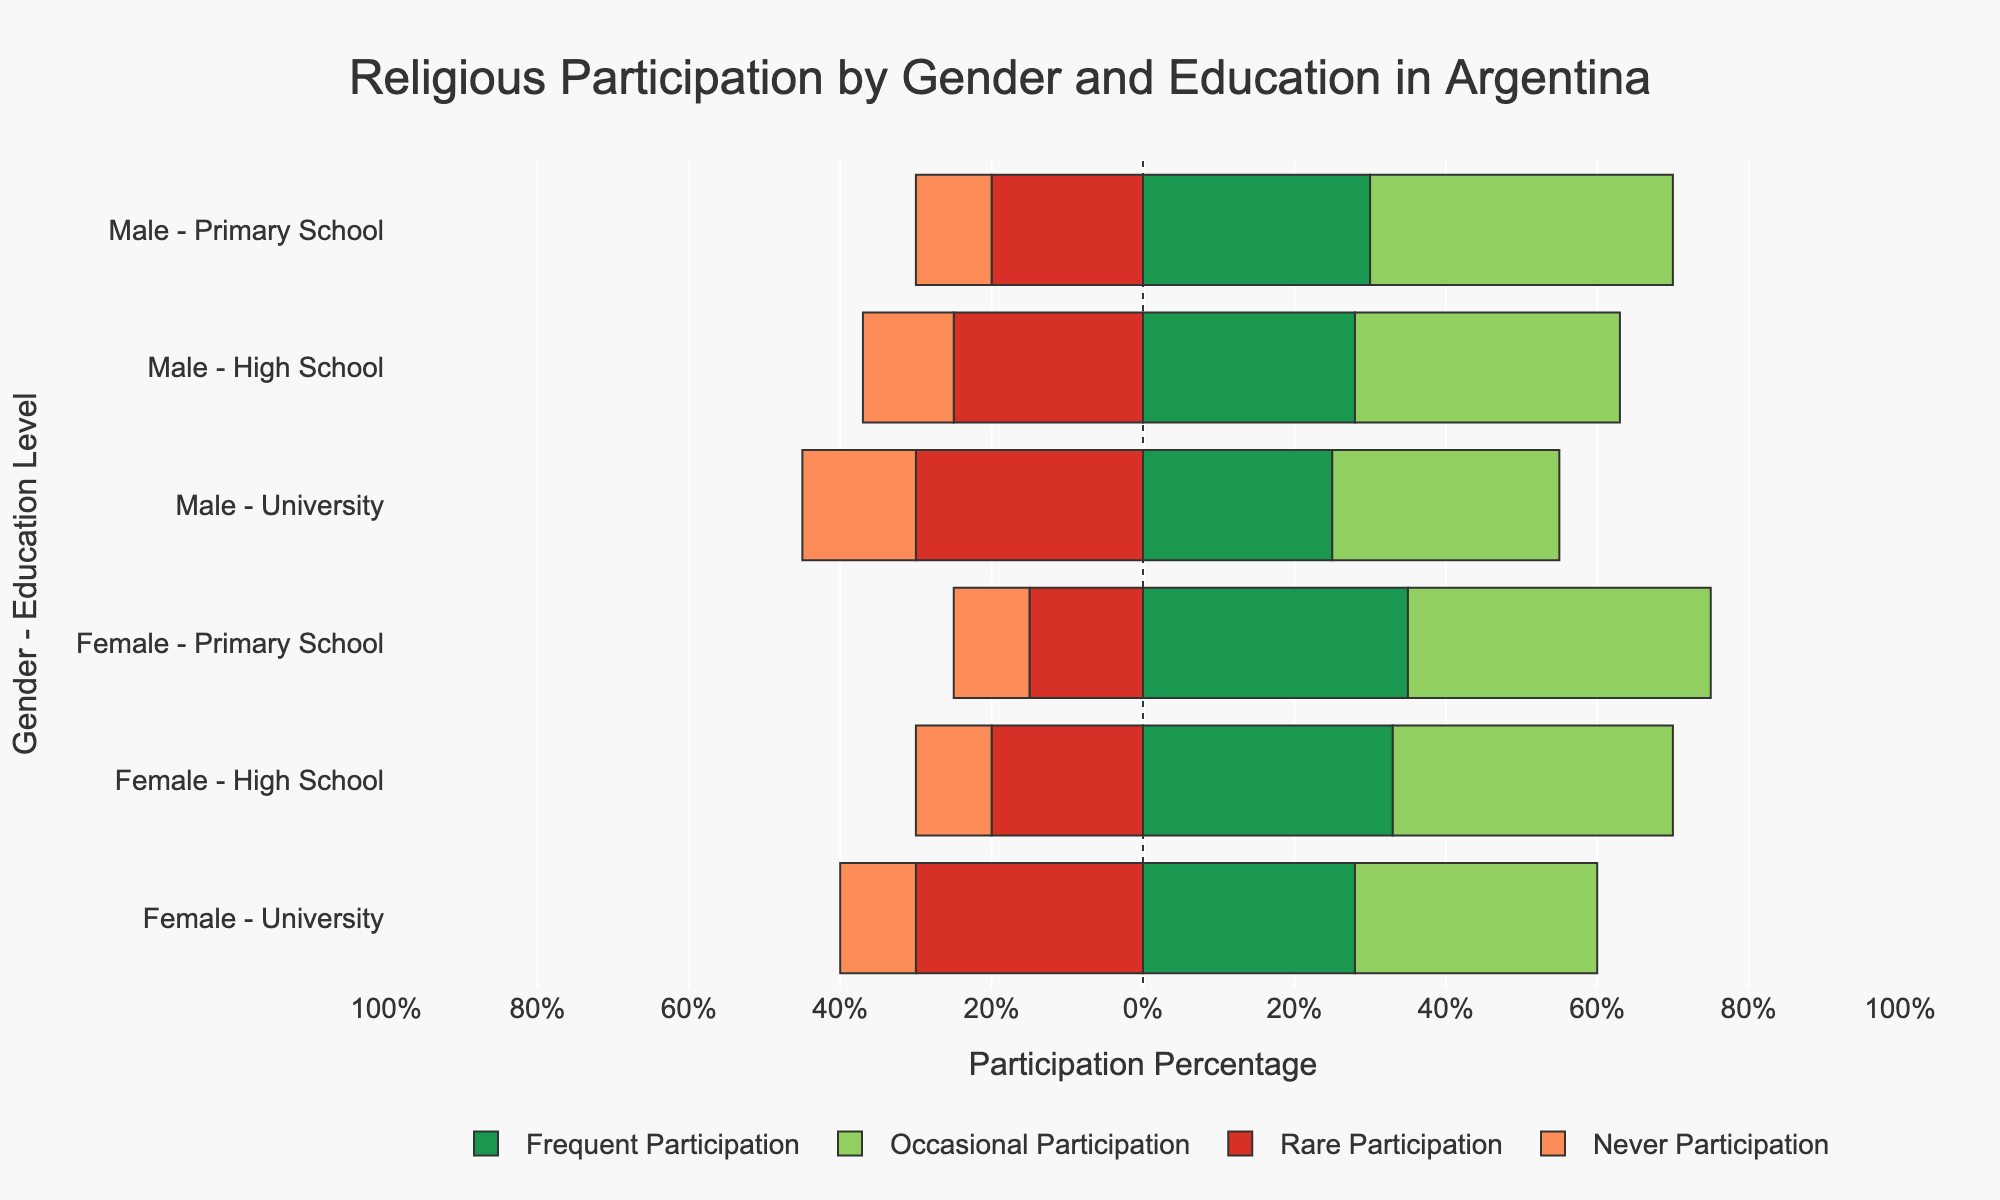Which gender and education level group has the highest percentage of frequent participation in religious activities? The highest percentage bar in the green color represents frequent participation. The bar for Female with Primary School education is the longest in green, indicating 35%, which is the highest.
Answer: Female with Primary School Which gender and education level group has the highest percentage of never participating in religious activities? The longest bar in the red color indicates never participation. The bar for Male with University education is the longest in red, showing 15%, which is the highest.
Answer: Male with University Compare the percentage of occasional participation between males and females with High School education. Which gender has a higher percentage? Look at the length of the green bars representing occasional participation for both genders with High School education. Females with High School education have a longer green bar (37%) compared to males (35%).
Answer: Females What is the total percentage for males with Primary School education who do not participate frequently in religious activities? Add together the percentages for occasional, rare, and never participation for males with Primary School education: 40% + 20% + 10% = 70%.
Answer: 70% By how much does the percentage of frequent participation among females with High School education exceed that of males with University education? Subtract the percentage of frequent participation for males with University education (25%) from that of females with High School education (33%): 33% - 25% = 8%.
Answer: 8% Which education level shows the most evenly balanced participation (Frequent, Occasional, Rare, Never) among females? Evaluate the female education levels and identify the one where the percentages are most evenly distributed. Females with University education exhibit the most balance: Frequent (28%), Occasional (32%), Rare (30%), Never (10%).
Answer: University Compare the sum of rare and never participation percentages between males with High School education and females with University education. Which group has a higher total? For males with High School education, sum rare and never participation: 25% + 12% = 37%. For females with University education, sum rare and never participation: 30% + 10% = 40%. Females with University education have the higher total.
Answer: Females with University 